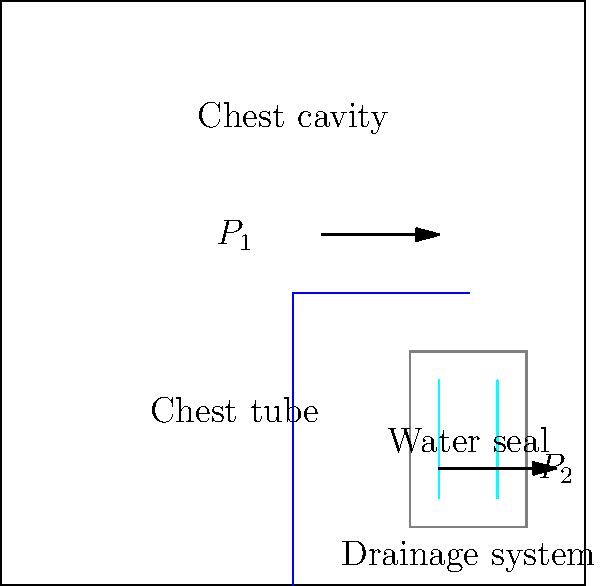In a chest drainage system, why is the water seal important, and what happens if air bubbles are seen in it? To understand the importance of the water seal in a chest drainage system, let's break it down step-by-step:

1. Purpose of the chest drainage system:
   - It helps remove air, blood, or fluid from the space around your lungs (called the pleural space).
   - This allows your lungs to expand properly and helps you breathe easier.

2. Components of the system:
   - Chest tube: connects your chest cavity to the drainage system.
   - Drainage container: collects the fluid or air from your chest.
   - Water seal: a chamber filled with water that acts as a one-way valve.

3. Function of the water seal:
   - It prevents air from going back into your chest cavity.
   - It allows air to exit from your chest but not re-enter.

4. How the water seal works:
   - As you breathe, the pressure in your chest cavity ($P_1$) changes.
   - When $P_1$ is higher than the pressure in the drainage system ($P_2$), air or fluid moves out of your chest.
   - The water seal lets this air pass through but stops it from flowing back when $P_1$ becomes lower than $P_2$.

5. Significance of bubbles in the water seal:
   - If you see bubbles in the water seal, it means air is still escaping from your chest.
   - This indicates that there's still an air leak in your lung or chest wall.

6. What bubbles tell your doctor:
   - Continuous bubbling: suggests an ongoing air leak that needs attention.
   - Intermittent bubbling: might be normal as it could be related to your breathing pattern.
   - No bubbles: could mean the air leak has sealed, which is generally a good sign.

Understanding these bubbles helps your doctor monitor your healing progress and decide when it's safe to remove the chest tube.
Answer: The water seal prevents air from re-entering the chest; bubbles indicate an ongoing air leak. 